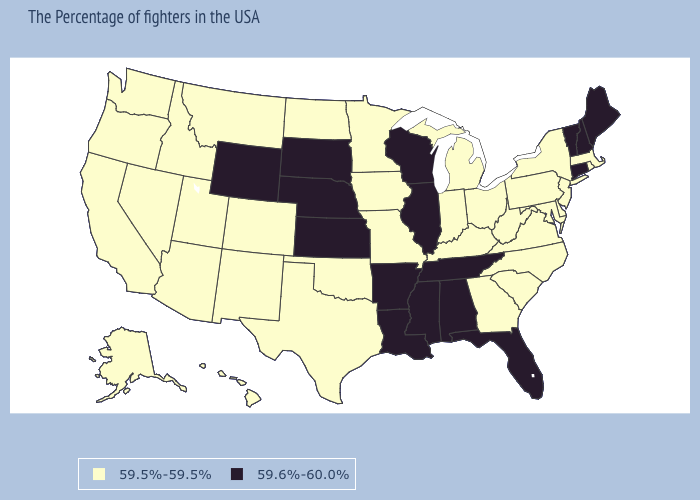Which states have the highest value in the USA?
Keep it brief. Maine, New Hampshire, Vermont, Connecticut, Florida, Alabama, Tennessee, Wisconsin, Illinois, Mississippi, Louisiana, Arkansas, Kansas, Nebraska, South Dakota, Wyoming. What is the value of Virginia?
Quick response, please. 59.5%-59.5%. What is the value of Tennessee?
Quick response, please. 59.6%-60.0%. Name the states that have a value in the range 59.6%-60.0%?
Short answer required. Maine, New Hampshire, Vermont, Connecticut, Florida, Alabama, Tennessee, Wisconsin, Illinois, Mississippi, Louisiana, Arkansas, Kansas, Nebraska, South Dakota, Wyoming. Which states have the lowest value in the USA?
Answer briefly. Massachusetts, Rhode Island, New York, New Jersey, Delaware, Maryland, Pennsylvania, Virginia, North Carolina, South Carolina, West Virginia, Ohio, Georgia, Michigan, Kentucky, Indiana, Missouri, Minnesota, Iowa, Oklahoma, Texas, North Dakota, Colorado, New Mexico, Utah, Montana, Arizona, Idaho, Nevada, California, Washington, Oregon, Alaska, Hawaii. Among the states that border Minnesota , which have the lowest value?
Short answer required. Iowa, North Dakota. What is the highest value in the West ?
Keep it brief. 59.6%-60.0%. What is the lowest value in the USA?
Give a very brief answer. 59.5%-59.5%. Name the states that have a value in the range 59.6%-60.0%?
Concise answer only. Maine, New Hampshire, Vermont, Connecticut, Florida, Alabama, Tennessee, Wisconsin, Illinois, Mississippi, Louisiana, Arkansas, Kansas, Nebraska, South Dakota, Wyoming. What is the lowest value in the USA?
Write a very short answer. 59.5%-59.5%. What is the value of South Carolina?
Quick response, please. 59.5%-59.5%. Does Arkansas have the highest value in the South?
Answer briefly. Yes. Does Connecticut have the lowest value in the USA?
Keep it brief. No. What is the lowest value in the USA?
Write a very short answer. 59.5%-59.5%. Does Missouri have the lowest value in the USA?
Keep it brief. Yes. 